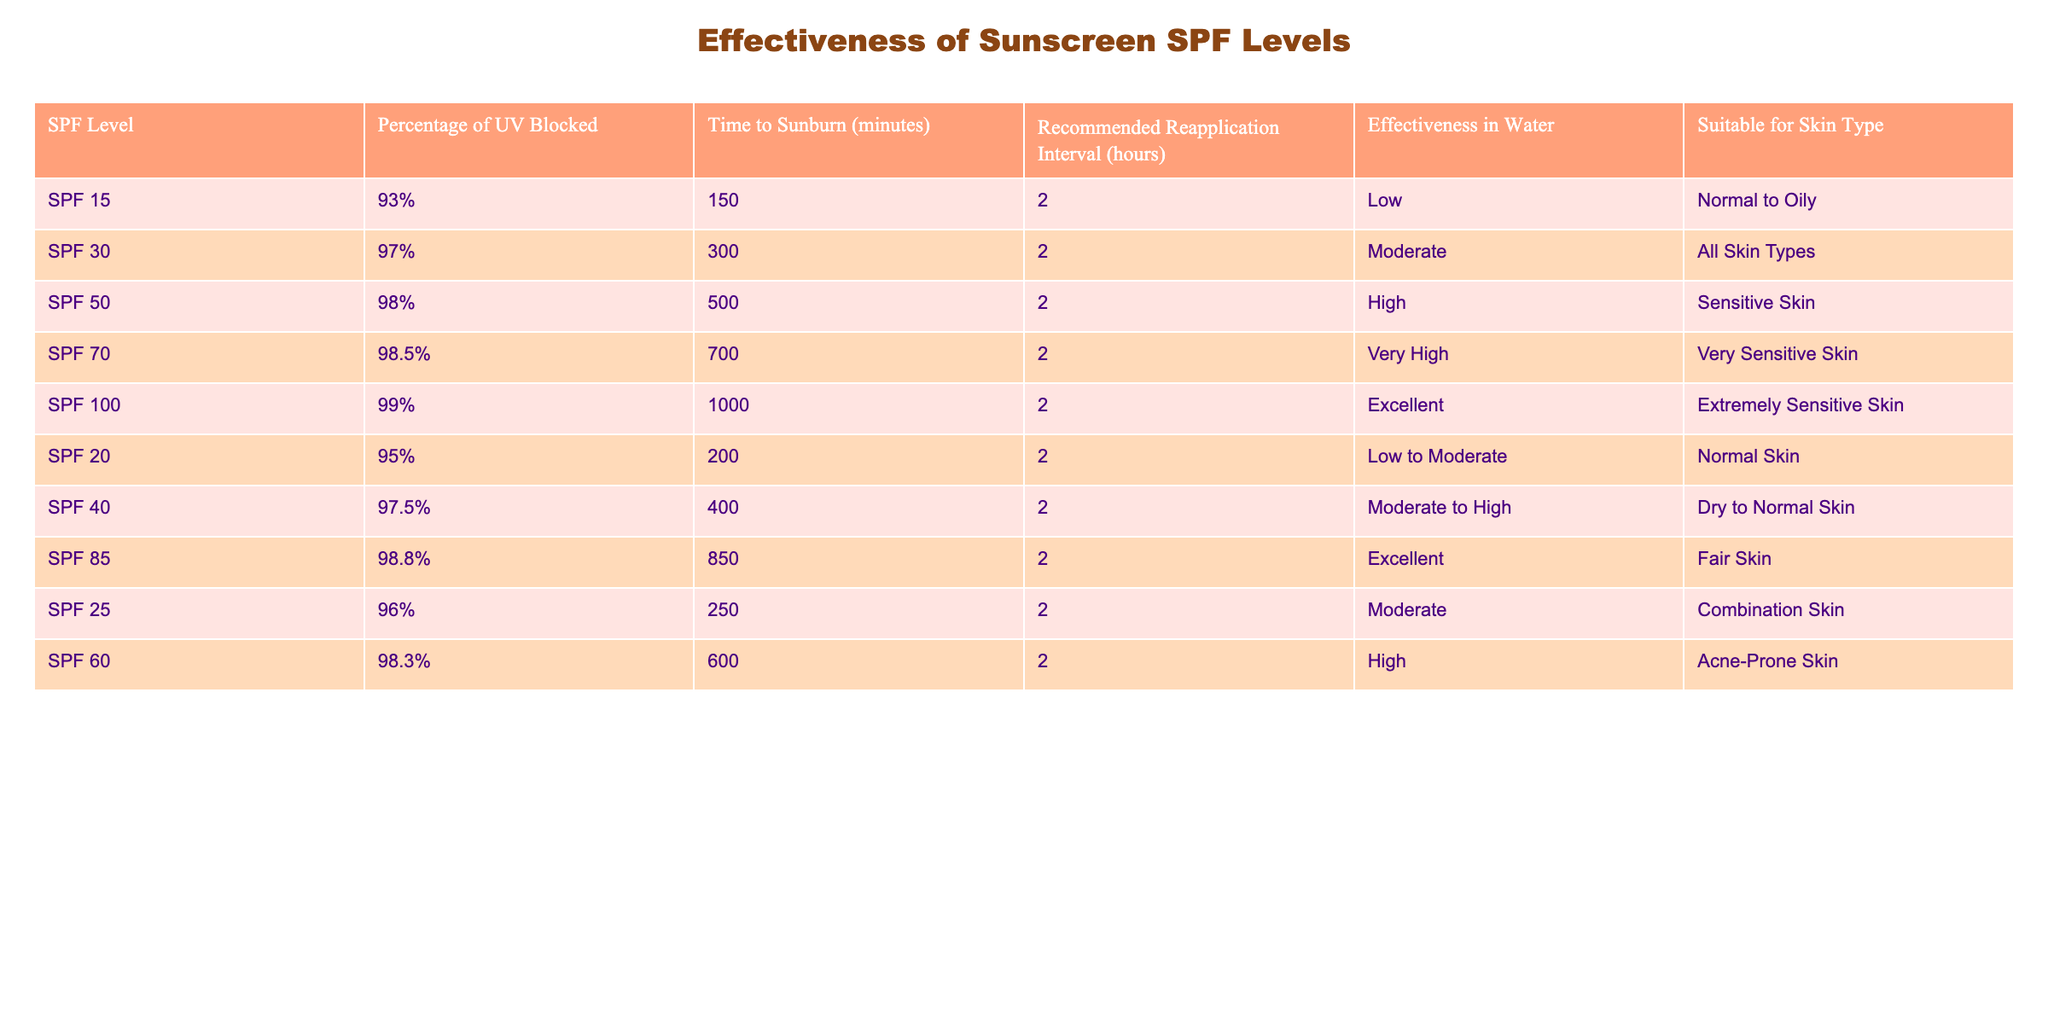What is the SPF level with the highest percentage of UV blocked? The SPF 100 level blocks 99% of UV rays, which is the highest value in the table.
Answer: SPF 100 How many minutes does SPF 30 allow before sunburn? According to the table, SPF 30 provides a time to sunburn of 300 minutes.
Answer: 300 minutes Is SPF 50 suitable for sensitive skin types? Yes, the table indicates that SPF 50 is suitable for sensitive skin.
Answer: Yes Which SPF level has the longest time to sunburn, and how long is it? The table shows that SPF 100 has the longest time to sunburn at 1000 minutes.
Answer: SPF 100, 1000 minutes What is the recommended reapplication interval for all SPF levels listed? The table states that the recommended reapplication interval for all SPF levels is 2 hours.
Answer: 2 hours Are SPF 15 and SPF 20 considered to have the same effectiveness in water? No, SPF 15 is categorized as low effectiveness in water while SPF 20 is considered low to moderate effectiveness, indicating a difference.
Answer: No What is the average percentage of UV blocked for SPF levels above 50? To find the average, sum the percentages (98% + 98.5% + 99%) and divide by 3, which equals (295.5%/3) = 98.5%.
Answer: 98.5% Which sunscreen is recommended for normal to oily skin? The table indicates SPF 15 is suitable for normal to oily skin types.
Answer: SPF 15 What SPF level blocks more than 98% of UV rays and is suitable for extremely sensitive skin? The table shows that SPF 100 blocks 99% of UV rays and is suitable for extremely sensitive skin.
Answer: SPF 100 How does the effectiveness in water vary for SPF levels from 15 to 100? SPF 15 and SPF 20 have low effectiveness, SPF 30 has moderate, SPF 40, SPF 50 high to very high, and SPF 100 has excellent effectiveness in water.
Answer: Varies from low to excellent 